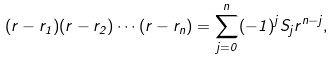<formula> <loc_0><loc_0><loc_500><loc_500>( r - r _ { 1 } ) ( r - r _ { 2 } ) \cdots ( r - r _ { n } ) = \sum _ { j = 0 } ^ { n } ( - 1 ) ^ { j } S _ { j } r ^ { n - j } ,</formula> 